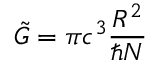<formula> <loc_0><loc_0><loc_500><loc_500>\tilde { G } = \pi c ^ { 3 } \frac { R ^ { 2 } } { \hbar { N } }</formula> 